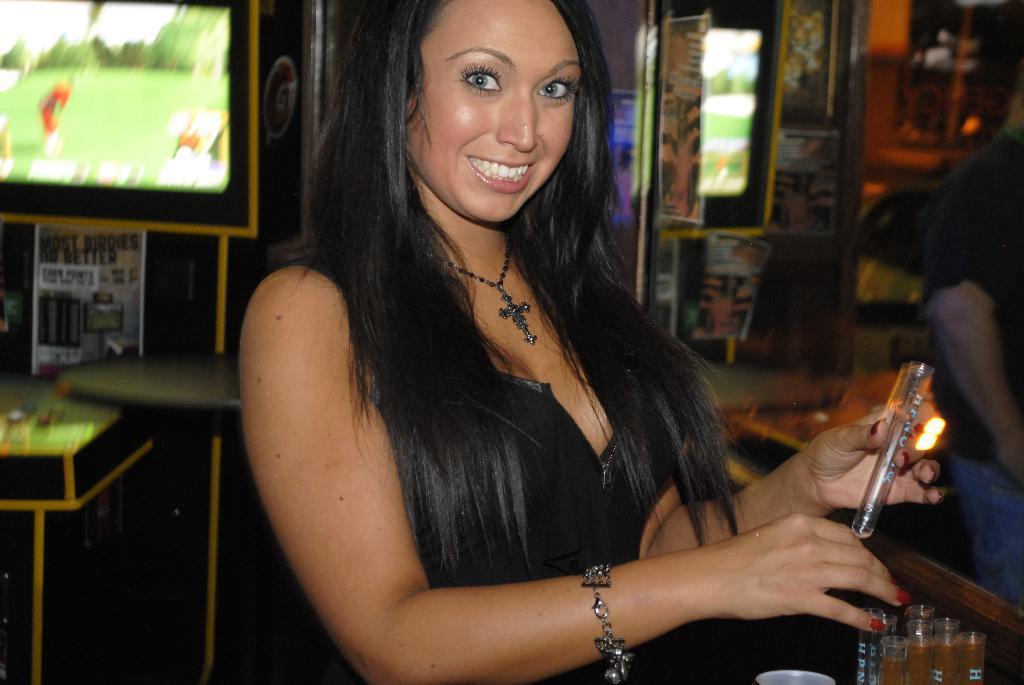Describe this image in one or two sentences. In the image we can see a woman standing, she is wearing clothes, bracelet, neck chain and she is smiling, and she is holding an object in hand. On the right side of the image we can see another person standing and wearing clothes. Here we can see the screens and the background is slightly blurred. 